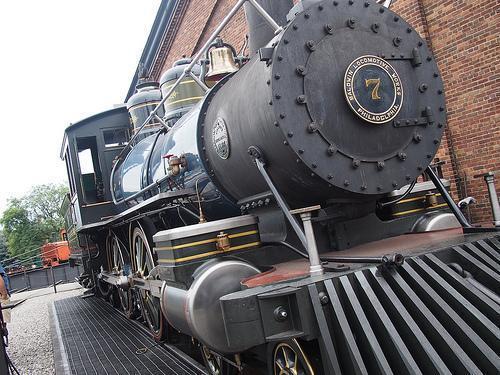How many trains are there?
Give a very brief answer. 1. 